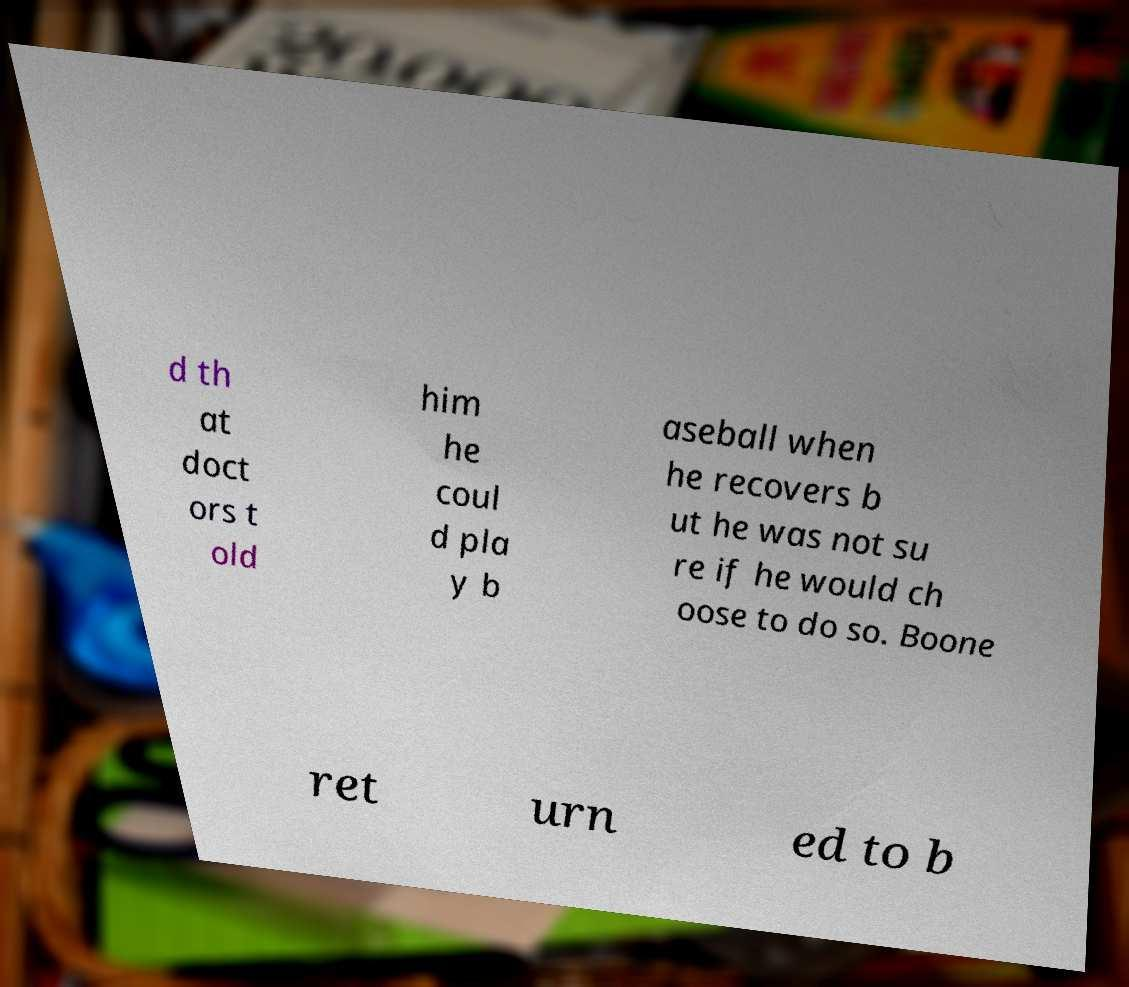What messages or text are displayed in this image? I need them in a readable, typed format. d th at doct ors t old him he coul d pla y b aseball when he recovers b ut he was not su re if he would ch oose to do so. Boone ret urn ed to b 